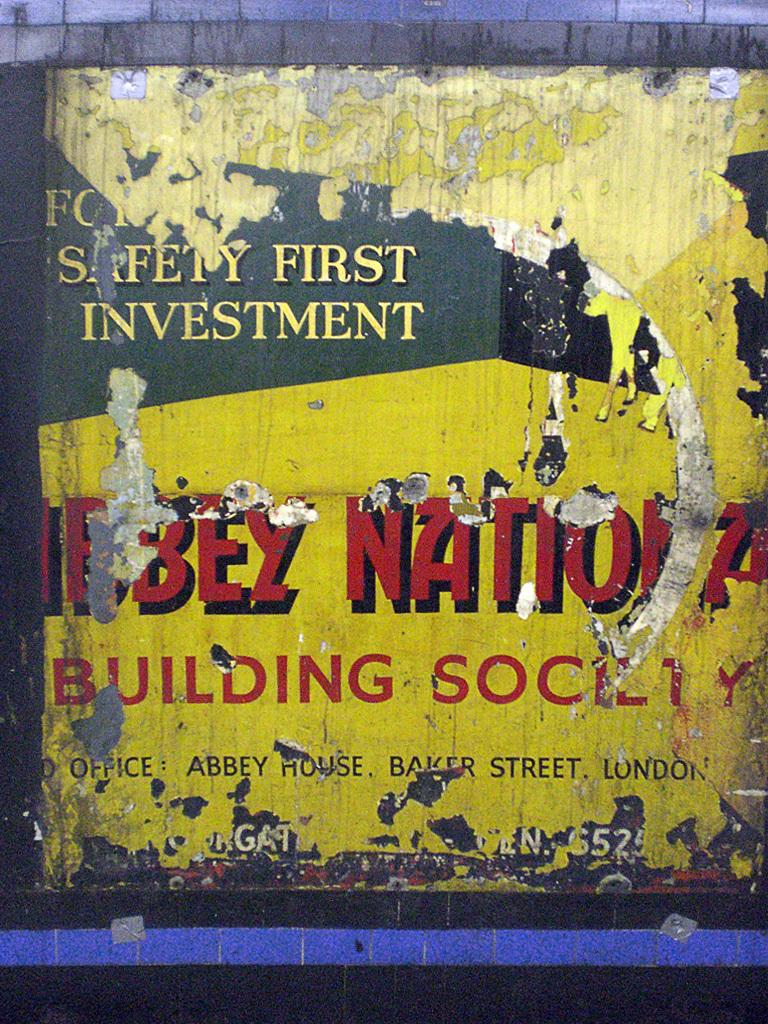<image>
Summarize the visual content of the image. A badly worn poster that says Building Society in red on a yellow background 